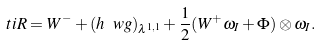<formula> <loc_0><loc_0><loc_500><loc_500>\ t i R = W ^ { - } + ( h \ w g ) _ { \lambda ^ { 1 , 1 } } + \frac { 1 } { 2 } ( W ^ { + } \omega _ { I } + \Phi ) \otimes \omega _ { I } .</formula> 